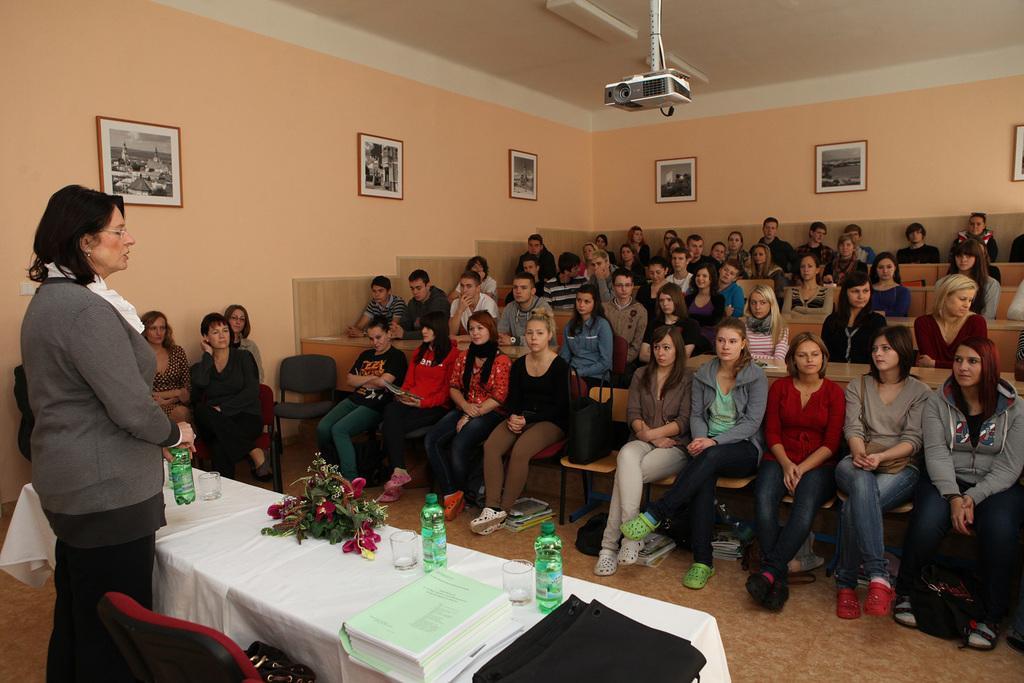Could you give a brief overview of what you see in this image? In the image there are many people sitting on benches in the back, on the left side there is a woman standing in front of table with papers,books,flower vase on it and there are photographs on the side of the wall with a projector in the middle of the ceiling. 